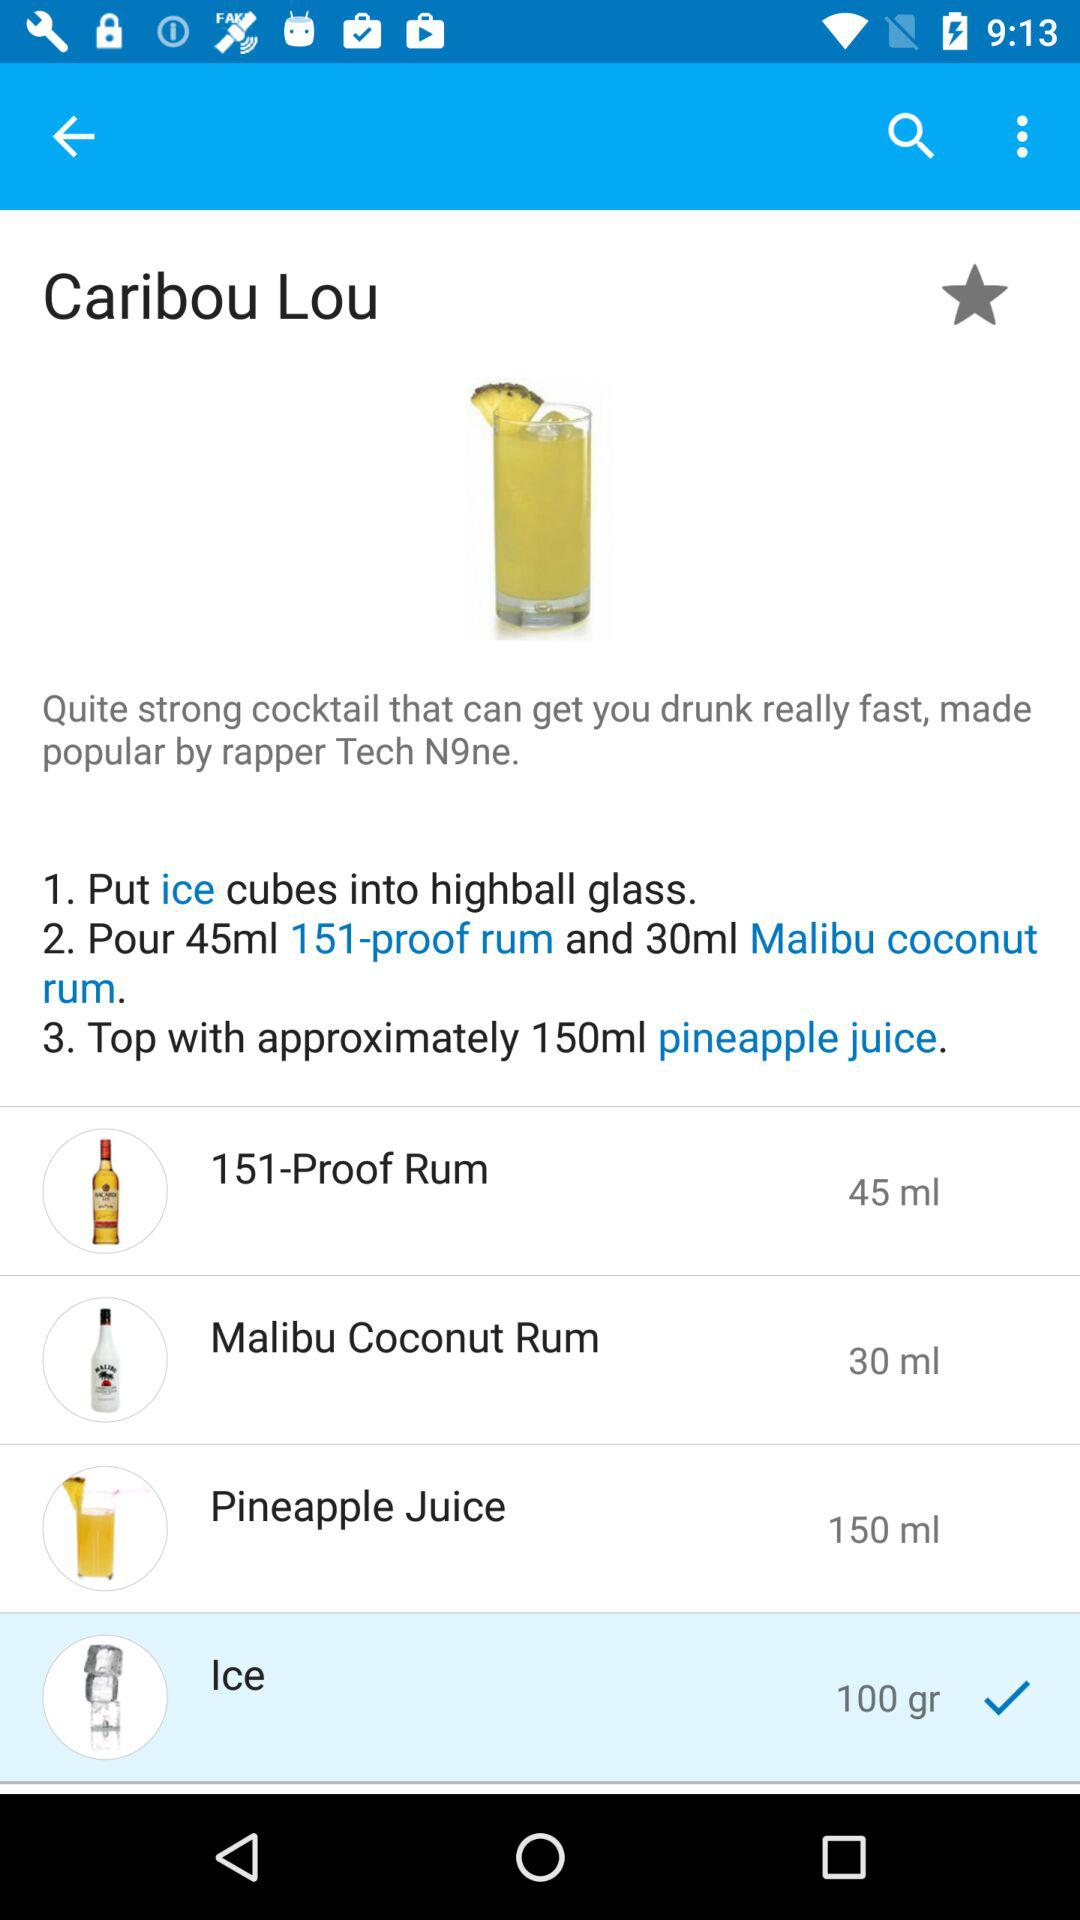What is the quantity of the "Malibu Coconut Rum"? The quantity is 30 ml. 